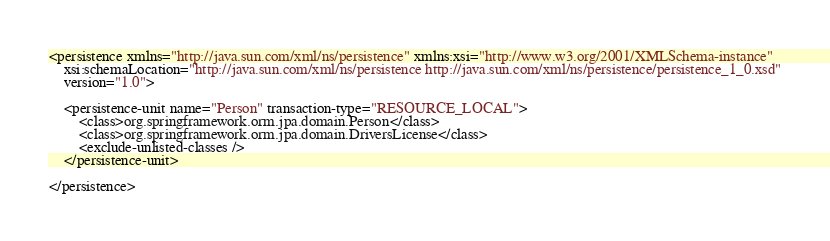<code> <loc_0><loc_0><loc_500><loc_500><_XML_><persistence xmlns="http://java.sun.com/xml/ns/persistence" xmlns:xsi="http://www.w3.org/2001/XMLSchema-instance"
	xsi:schemaLocation="http://java.sun.com/xml/ns/persistence http://java.sun.com/xml/ns/persistence/persistence_1_0.xsd"
	version="1.0">

	<persistence-unit name="Person" transaction-type="RESOURCE_LOCAL">
		<class>org.springframework.orm.jpa.domain.Person</class>
		<class>org.springframework.orm.jpa.domain.DriversLicense</class>
		<exclude-unlisted-classes />
	</persistence-unit>

</persistence>
</code> 